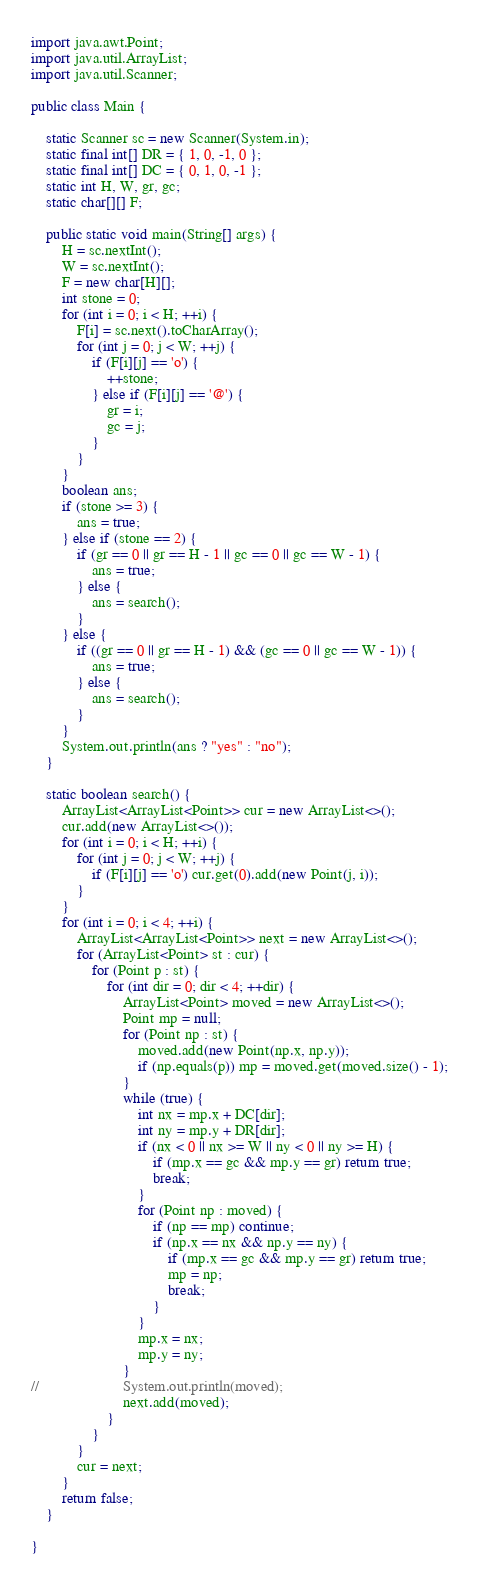<code> <loc_0><loc_0><loc_500><loc_500><_Java_>import java.awt.Point;
import java.util.ArrayList;
import java.util.Scanner;

public class Main {

	static Scanner sc = new Scanner(System.in);
	static final int[] DR = { 1, 0, -1, 0 };
	static final int[] DC = { 0, 1, 0, -1 };
	static int H, W, gr, gc;
	static char[][] F;

	public static void main(String[] args) {
		H = sc.nextInt();
		W = sc.nextInt();
		F = new char[H][];
		int stone = 0;
		for (int i = 0; i < H; ++i) {
			F[i] = sc.next().toCharArray();
			for (int j = 0; j < W; ++j) {
				if (F[i][j] == 'o') {
					++stone;
				} else if (F[i][j] == '@') {
					gr = i;
					gc = j;
				}
			}
		}
		boolean ans;
		if (stone >= 3) {
			ans = true;
		} else if (stone == 2) {
			if (gr == 0 || gr == H - 1 || gc == 0 || gc == W - 1) {
				ans = true;
			} else {
				ans = search();
			}
		} else {
			if ((gr == 0 || gr == H - 1) && (gc == 0 || gc == W - 1)) {
				ans = true;
			} else {
				ans = search();
			}
		}
		System.out.println(ans ? "yes" : "no");
	}

	static boolean search() {
		ArrayList<ArrayList<Point>> cur = new ArrayList<>();
		cur.add(new ArrayList<>());
		for (int i = 0; i < H; ++i) {
			for (int j = 0; j < W; ++j) {
				if (F[i][j] == 'o') cur.get(0).add(new Point(j, i));
			}
		}
		for (int i = 0; i < 4; ++i) {
			ArrayList<ArrayList<Point>> next = new ArrayList<>();
			for (ArrayList<Point> st : cur) {
				for (Point p : st) {
					for (int dir = 0; dir < 4; ++dir) {
						ArrayList<Point> moved = new ArrayList<>();
						Point mp = null;
						for (Point np : st) {
							moved.add(new Point(np.x, np.y));
							if (np.equals(p)) mp = moved.get(moved.size() - 1);
						}
						while (true) {
							int nx = mp.x + DC[dir];
							int ny = mp.y + DR[dir];
							if (nx < 0 || nx >= W || ny < 0 || ny >= H) {
								if (mp.x == gc && mp.y == gr) return true;
								break;
							}
							for (Point np : moved) {
								if (np == mp) continue;
								if (np.x == nx && np.y == ny) {
									if (mp.x == gc && mp.y == gr) return true;
									mp = np;
									break;
								}
							}
							mp.x = nx;
							mp.y = ny;
						}
//						System.out.println(moved);
						next.add(moved);
					}
				}
			}
			cur = next;
		}
		return false;
	}

}</code> 